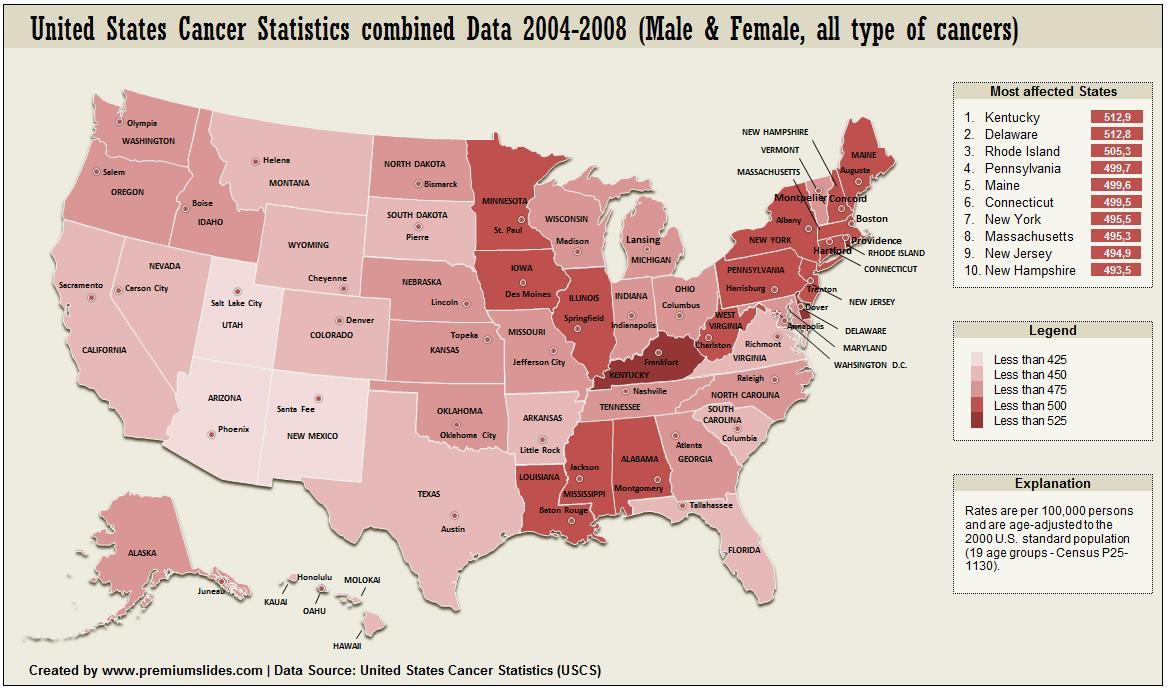What all sex have been considered in the statistics
Answer the question with a short phrase. Male & Female as per legend how much does Kentucky have less than 525 as per legend how much does Utah have less than 425 as per legend how much does west virginia have less than 500 as per legend how much does Hawai have less than 450 how much is Maine and New York together 9951 